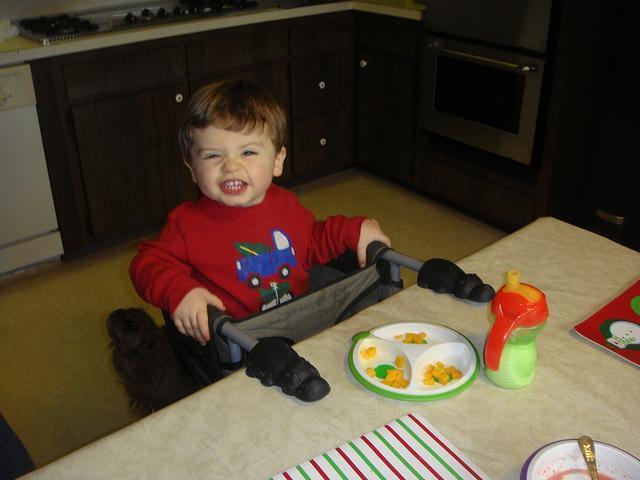Does the description: "The truck is at the right side of the person." accurately reflect the image?
Answer yes or no. No. 